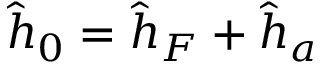Convert formula to latex. <formula><loc_0><loc_0><loc_500><loc_500>\hat { h } _ { 0 } = \hat { h } _ { F } + \hat { h } _ { a }</formula> 